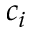<formula> <loc_0><loc_0><loc_500><loc_500>c _ { i }</formula> 